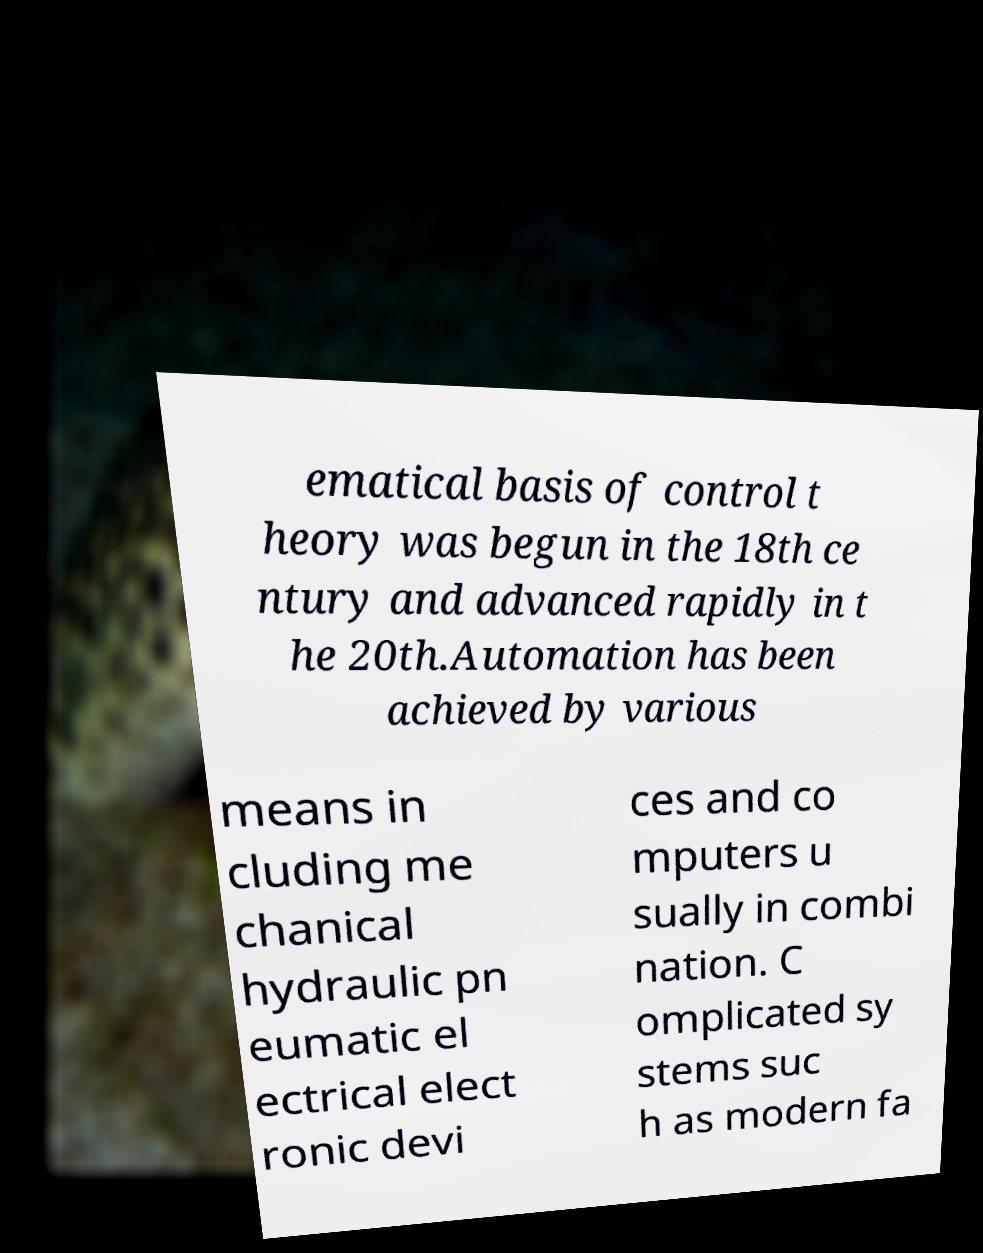Could you assist in decoding the text presented in this image and type it out clearly? ematical basis of control t heory was begun in the 18th ce ntury and advanced rapidly in t he 20th.Automation has been achieved by various means in cluding me chanical hydraulic pn eumatic el ectrical elect ronic devi ces and co mputers u sually in combi nation. C omplicated sy stems suc h as modern fa 